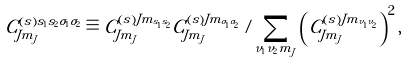<formula> <loc_0><loc_0><loc_500><loc_500>C _ { J m _ { J } } ^ { \left ( s \right ) s _ { 1 } s _ { 2 } \sigma _ { 1 } \sigma _ { 2 } } \equiv C _ { J m _ { J } } ^ { \left ( s \right ) J m _ { s _ { 1 } s _ { 2 } } } C _ { J m _ { J } } ^ { \left ( s \right ) J m _ { \sigma _ { 1 } \sigma _ { 2 } } } / \sum _ { \nu _ { 1 } \nu _ { 2 } m _ { J } } \left ( C _ { J m _ { J } } ^ { \left ( s \right ) J m _ { \nu _ { 1 } \nu _ { 2 } } } \right ) ^ { 2 } ,</formula> 